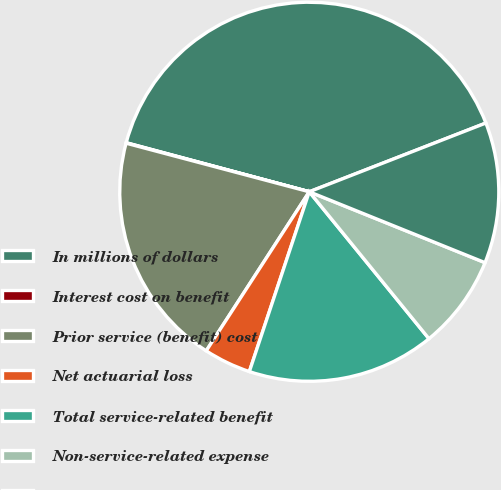Convert chart. <chart><loc_0><loc_0><loc_500><loc_500><pie_chart><fcel>In millions of dollars<fcel>Interest cost on benefit<fcel>Prior service (benefit) cost<fcel>Net actuarial loss<fcel>Total service-related benefit<fcel>Non-service-related expense<fcel>Total net expense (benefit)<nl><fcel>39.93%<fcel>0.04%<fcel>19.98%<fcel>4.03%<fcel>16.0%<fcel>8.02%<fcel>12.01%<nl></chart> 